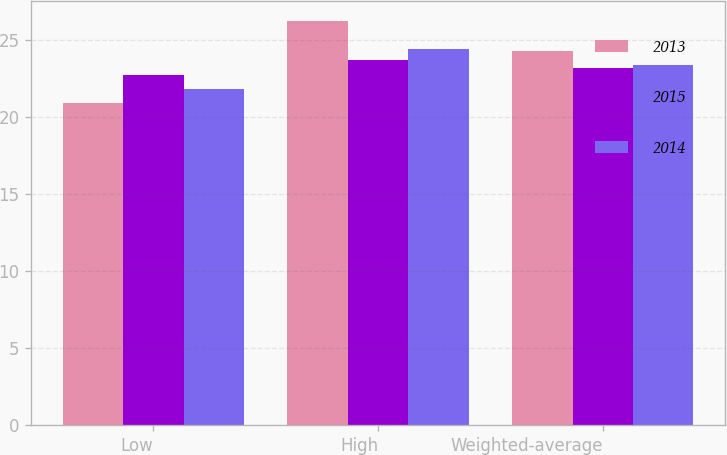Convert chart to OTSL. <chart><loc_0><loc_0><loc_500><loc_500><stacked_bar_chart><ecel><fcel>Low<fcel>High<fcel>Weighted-average<nl><fcel>2013<fcel>20.9<fcel>26.2<fcel>24.3<nl><fcel>2015<fcel>22.7<fcel>23.7<fcel>23.2<nl><fcel>2014<fcel>21.8<fcel>24.4<fcel>23.38<nl></chart> 